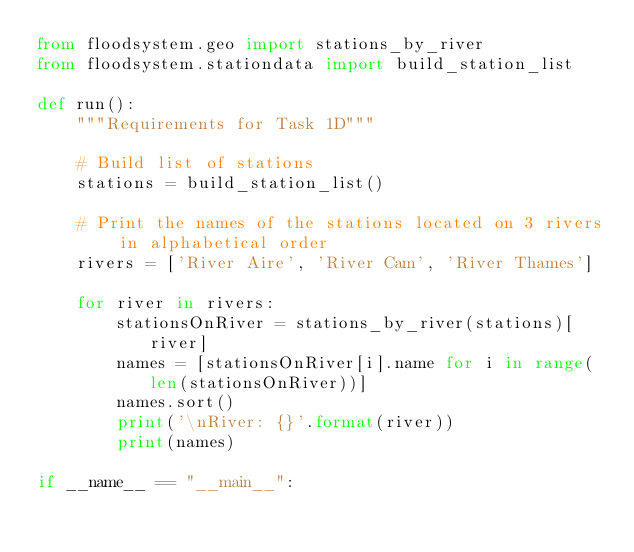Convert code to text. <code><loc_0><loc_0><loc_500><loc_500><_Python_>from floodsystem.geo import stations_by_river
from floodsystem.stationdata import build_station_list

def run():
    """Requirements for Task 1D"""

    # Build list of stations
    stations = build_station_list()

    # Print the names of the stations located on 3 rivers in alphabetical order
    rivers = ['River Aire', 'River Cam', 'River Thames']
    
    for river in rivers:
        stationsOnRiver = stations_by_river(stations)[river]
        names = [stationsOnRiver[i].name for i in range(len(stationsOnRiver))]
        names.sort()
        print('\nRiver: {}'.format(river))
        print(names)

if __name__ == "__main__":</code> 